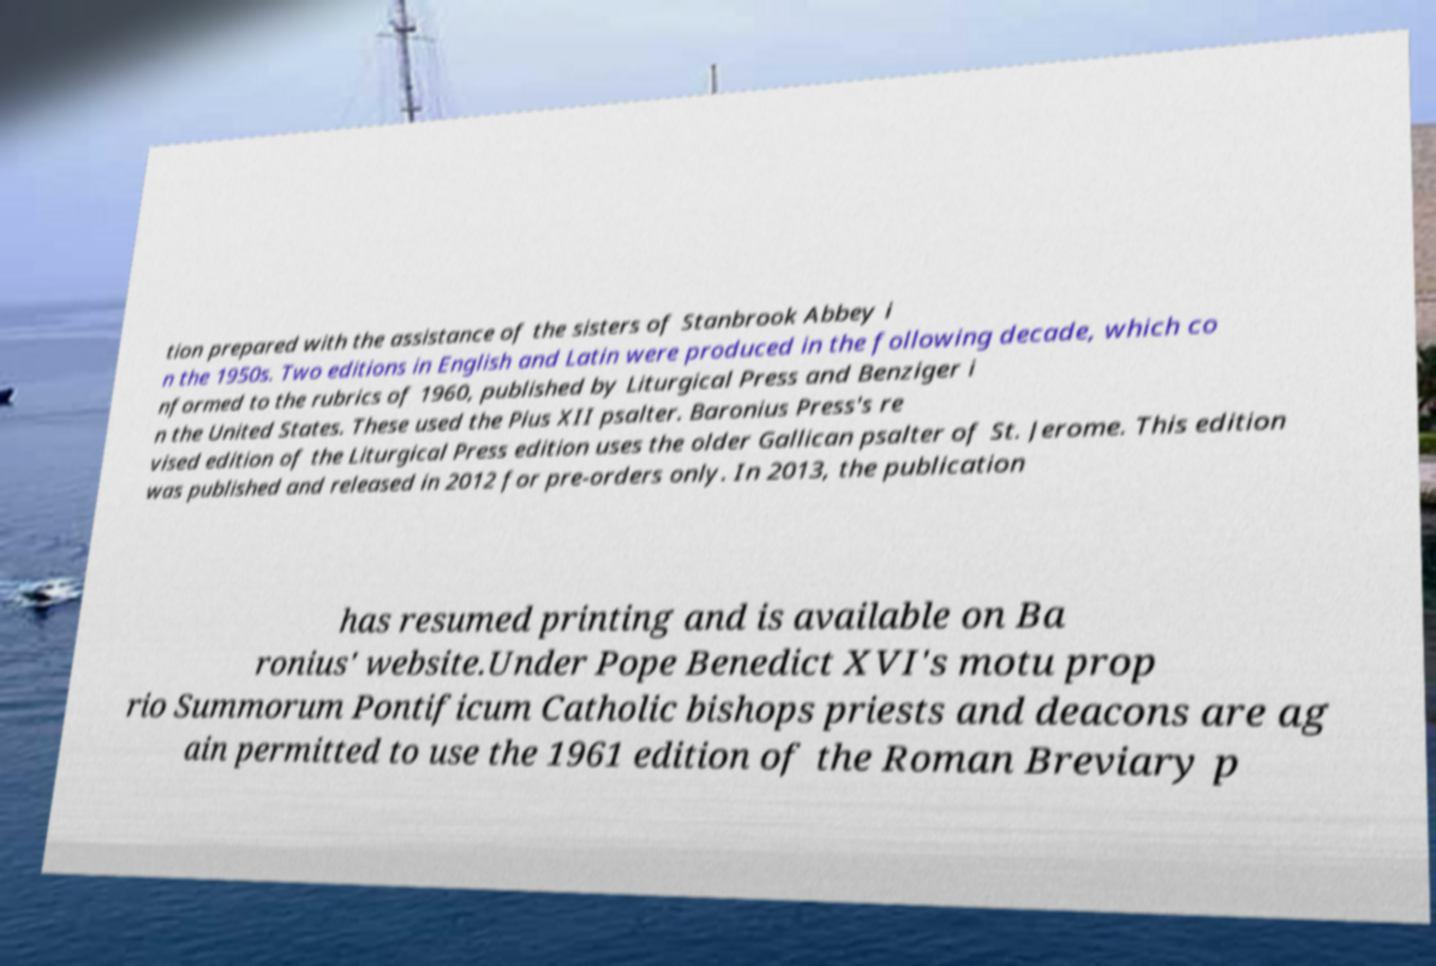What messages or text are displayed in this image? I need them in a readable, typed format. tion prepared with the assistance of the sisters of Stanbrook Abbey i n the 1950s. Two editions in English and Latin were produced in the following decade, which co nformed to the rubrics of 1960, published by Liturgical Press and Benziger i n the United States. These used the Pius XII psalter. Baronius Press's re vised edition of the Liturgical Press edition uses the older Gallican psalter of St. Jerome. This edition was published and released in 2012 for pre-orders only. In 2013, the publication has resumed printing and is available on Ba ronius' website.Under Pope Benedict XVI's motu prop rio Summorum Pontificum Catholic bishops priests and deacons are ag ain permitted to use the 1961 edition of the Roman Breviary p 